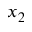Convert formula to latex. <formula><loc_0><loc_0><loc_500><loc_500>x _ { 2 }</formula> 